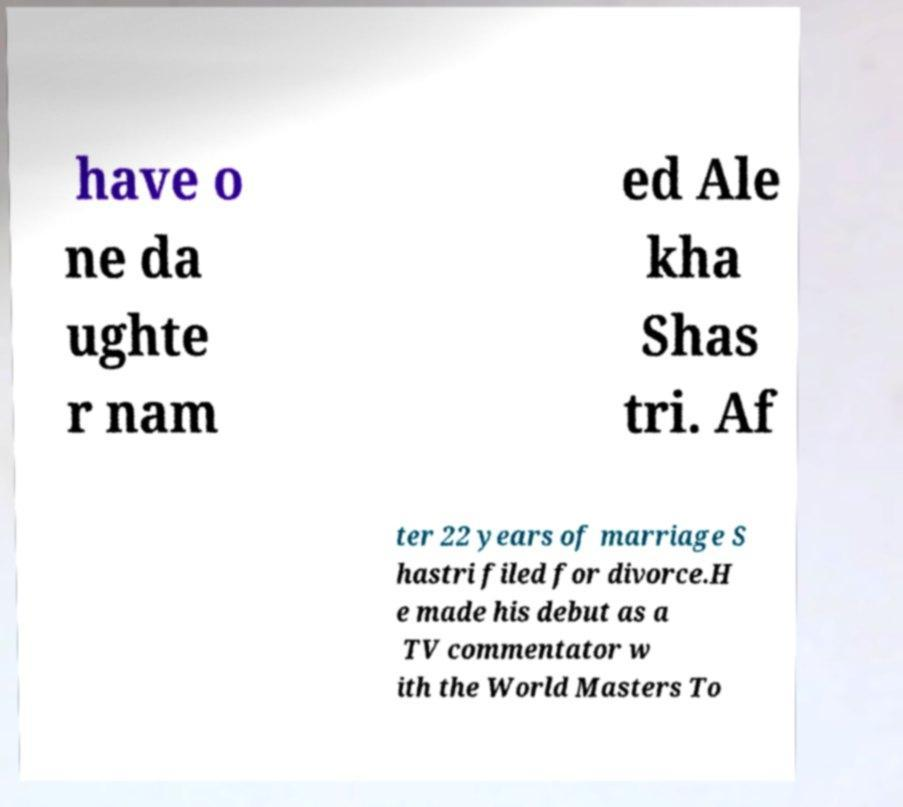Could you extract and type out the text from this image? have o ne da ughte r nam ed Ale kha Shas tri. Af ter 22 years of marriage S hastri filed for divorce.H e made his debut as a TV commentator w ith the World Masters To 